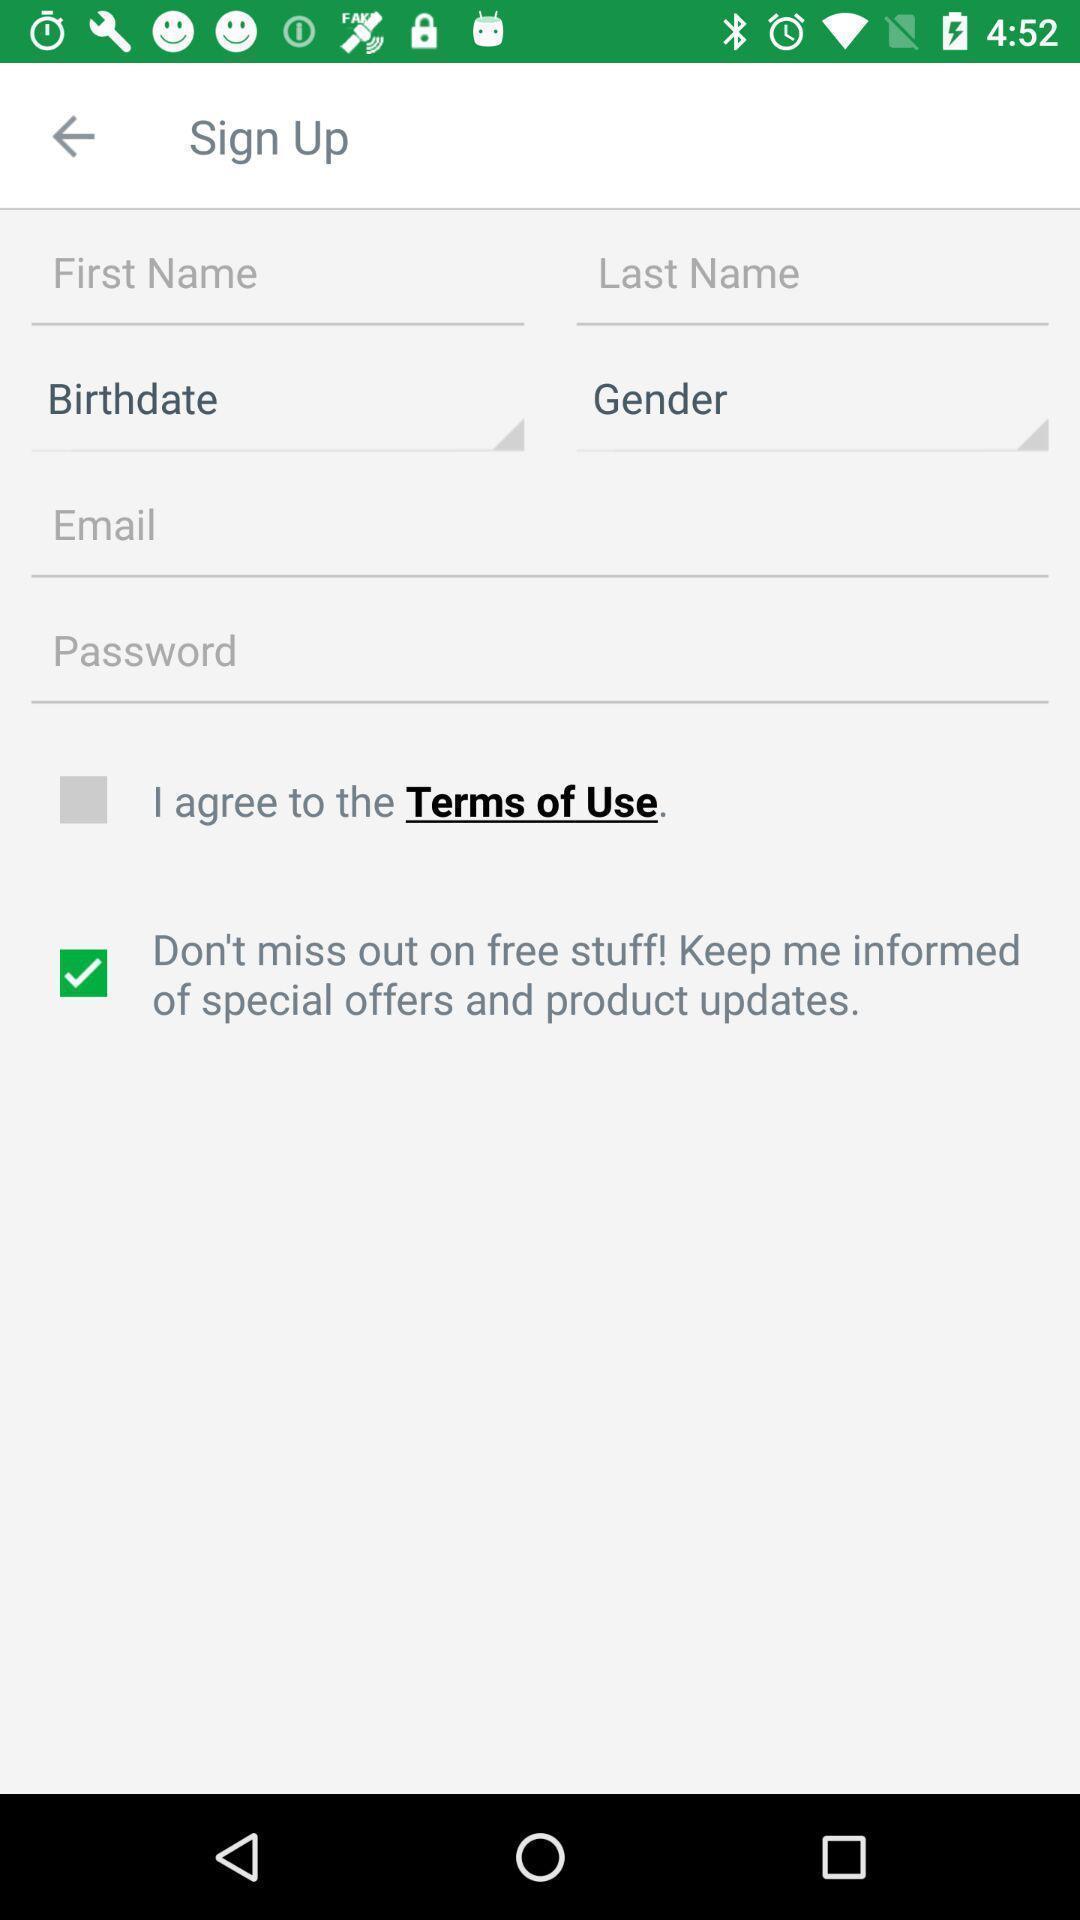Tell me about the visual elements in this screen capture. Sign up page. 